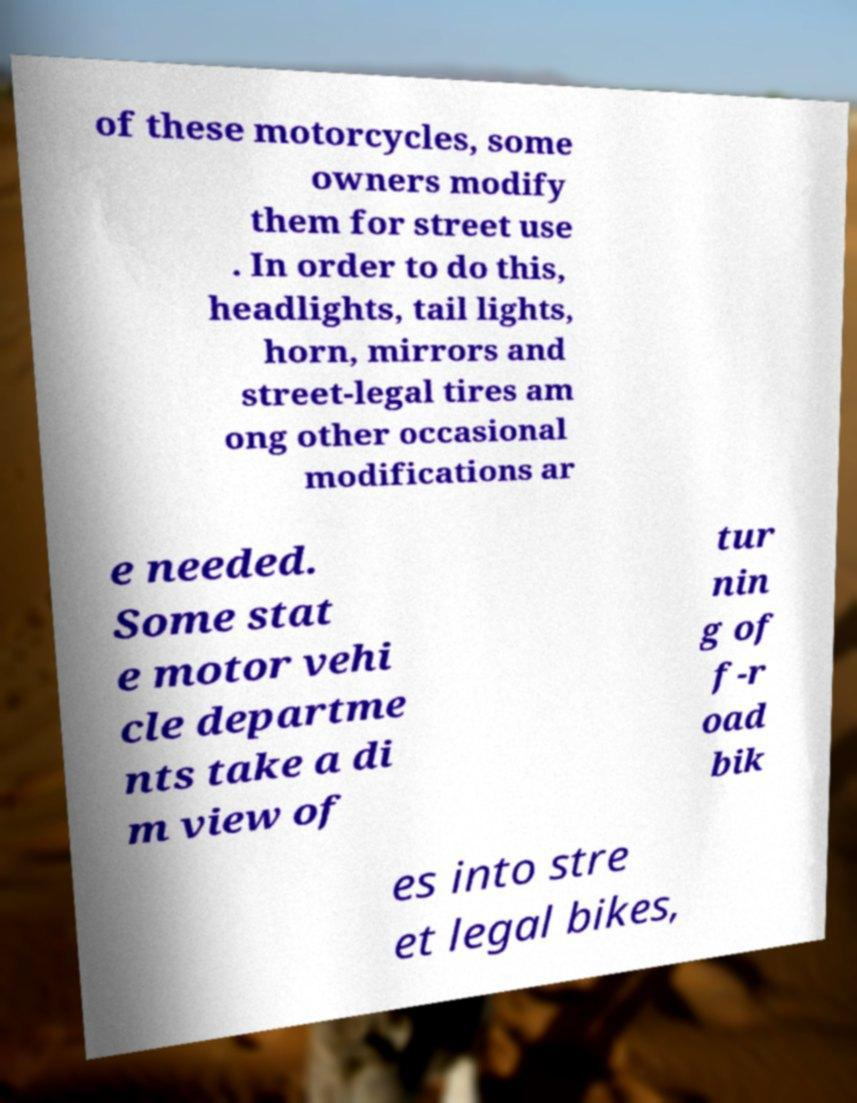Could you assist in decoding the text presented in this image and type it out clearly? of these motorcycles, some owners modify them for street use . In order to do this, headlights, tail lights, horn, mirrors and street-legal tires am ong other occasional modifications ar e needed. Some stat e motor vehi cle departme nts take a di m view of tur nin g of f-r oad bik es into stre et legal bikes, 